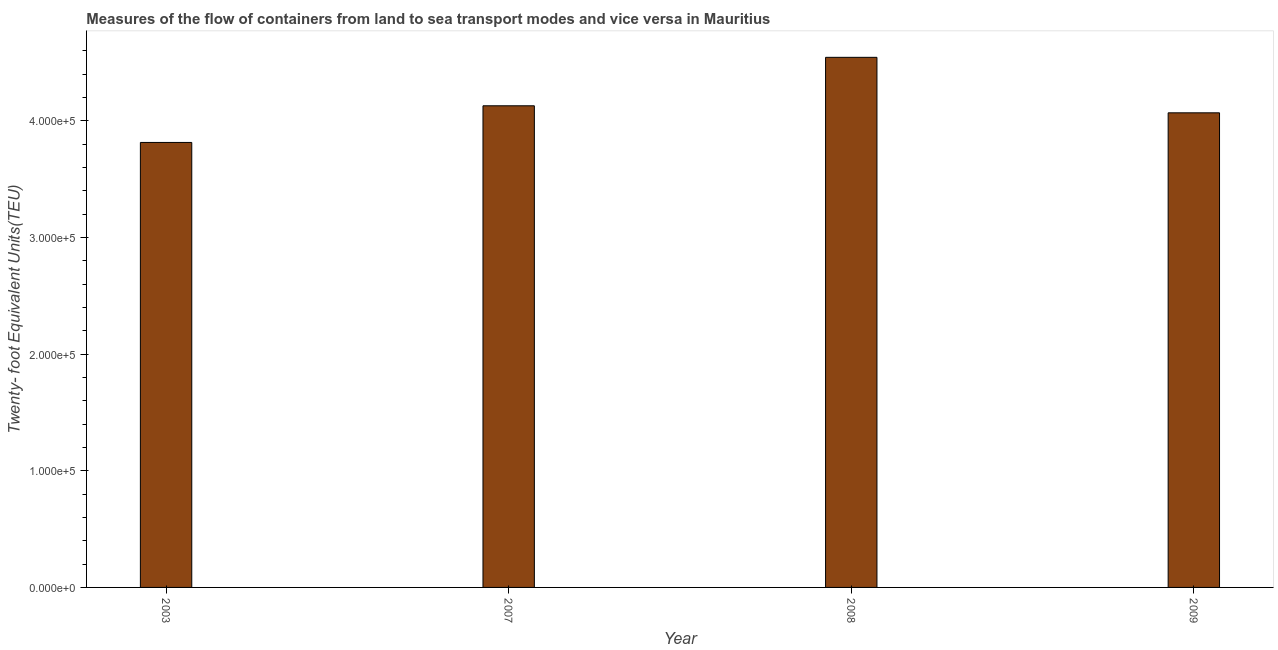Does the graph contain any zero values?
Keep it short and to the point. No. What is the title of the graph?
Offer a terse response. Measures of the flow of containers from land to sea transport modes and vice versa in Mauritius. What is the label or title of the X-axis?
Ensure brevity in your answer.  Year. What is the label or title of the Y-axis?
Provide a succinct answer. Twenty- foot Equivalent Units(TEU). What is the container port traffic in 2003?
Offer a terse response. 3.81e+05. Across all years, what is the maximum container port traffic?
Offer a terse response. 4.54e+05. Across all years, what is the minimum container port traffic?
Offer a very short reply. 3.81e+05. In which year was the container port traffic maximum?
Your answer should be compact. 2008. What is the sum of the container port traffic?
Give a very brief answer. 1.66e+06. What is the difference between the container port traffic in 2007 and 2008?
Provide a succinct answer. -4.15e+04. What is the average container port traffic per year?
Your answer should be very brief. 4.14e+05. What is the median container port traffic?
Your answer should be very brief. 4.10e+05. In how many years, is the container port traffic greater than 80000 TEU?
Offer a terse response. 4. Do a majority of the years between 2008 and 2009 (inclusive) have container port traffic greater than 380000 TEU?
Your answer should be compact. Yes. What is the ratio of the container port traffic in 2008 to that in 2009?
Offer a very short reply. 1.12. Is the container port traffic in 2007 less than that in 2008?
Your response must be concise. Yes. Is the difference between the container port traffic in 2007 and 2009 greater than the difference between any two years?
Offer a very short reply. No. What is the difference between the highest and the second highest container port traffic?
Offer a terse response. 4.15e+04. What is the difference between the highest and the lowest container port traffic?
Offer a very short reply. 7.30e+04. How many bars are there?
Provide a short and direct response. 4. What is the difference between two consecutive major ticks on the Y-axis?
Keep it short and to the point. 1.00e+05. What is the Twenty- foot Equivalent Units(TEU) in 2003?
Your answer should be very brief. 3.81e+05. What is the Twenty- foot Equivalent Units(TEU) in 2007?
Your answer should be very brief. 4.13e+05. What is the Twenty- foot Equivalent Units(TEU) in 2008?
Offer a terse response. 4.54e+05. What is the Twenty- foot Equivalent Units(TEU) of 2009?
Provide a succinct answer. 4.07e+05. What is the difference between the Twenty- foot Equivalent Units(TEU) in 2003 and 2007?
Offer a terse response. -3.14e+04. What is the difference between the Twenty- foot Equivalent Units(TEU) in 2003 and 2008?
Provide a short and direct response. -7.30e+04. What is the difference between the Twenty- foot Equivalent Units(TEU) in 2003 and 2009?
Ensure brevity in your answer.  -2.54e+04. What is the difference between the Twenty- foot Equivalent Units(TEU) in 2007 and 2008?
Ensure brevity in your answer.  -4.15e+04. What is the difference between the Twenty- foot Equivalent Units(TEU) in 2007 and 2009?
Give a very brief answer. 6034. What is the difference between the Twenty- foot Equivalent Units(TEU) in 2008 and 2009?
Ensure brevity in your answer.  4.76e+04. What is the ratio of the Twenty- foot Equivalent Units(TEU) in 2003 to that in 2007?
Your answer should be very brief. 0.92. What is the ratio of the Twenty- foot Equivalent Units(TEU) in 2003 to that in 2008?
Provide a short and direct response. 0.84. What is the ratio of the Twenty- foot Equivalent Units(TEU) in 2003 to that in 2009?
Provide a short and direct response. 0.94. What is the ratio of the Twenty- foot Equivalent Units(TEU) in 2007 to that in 2008?
Provide a succinct answer. 0.91. What is the ratio of the Twenty- foot Equivalent Units(TEU) in 2007 to that in 2009?
Ensure brevity in your answer.  1.01. What is the ratio of the Twenty- foot Equivalent Units(TEU) in 2008 to that in 2009?
Offer a very short reply. 1.12. 